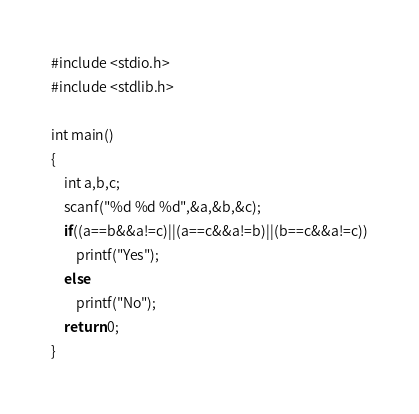<code> <loc_0><loc_0><loc_500><loc_500><_C_>#include <stdio.h>
#include <stdlib.h>

int main()
{
    int a,b,c;
    scanf("%d %d %d",&a,&b,&c);
    if((a==b&&a!=c)||(a==c&&a!=b)||(b==c&&a!=c))
        printf("Yes");
    else
        printf("No");
    return 0;
}</code> 